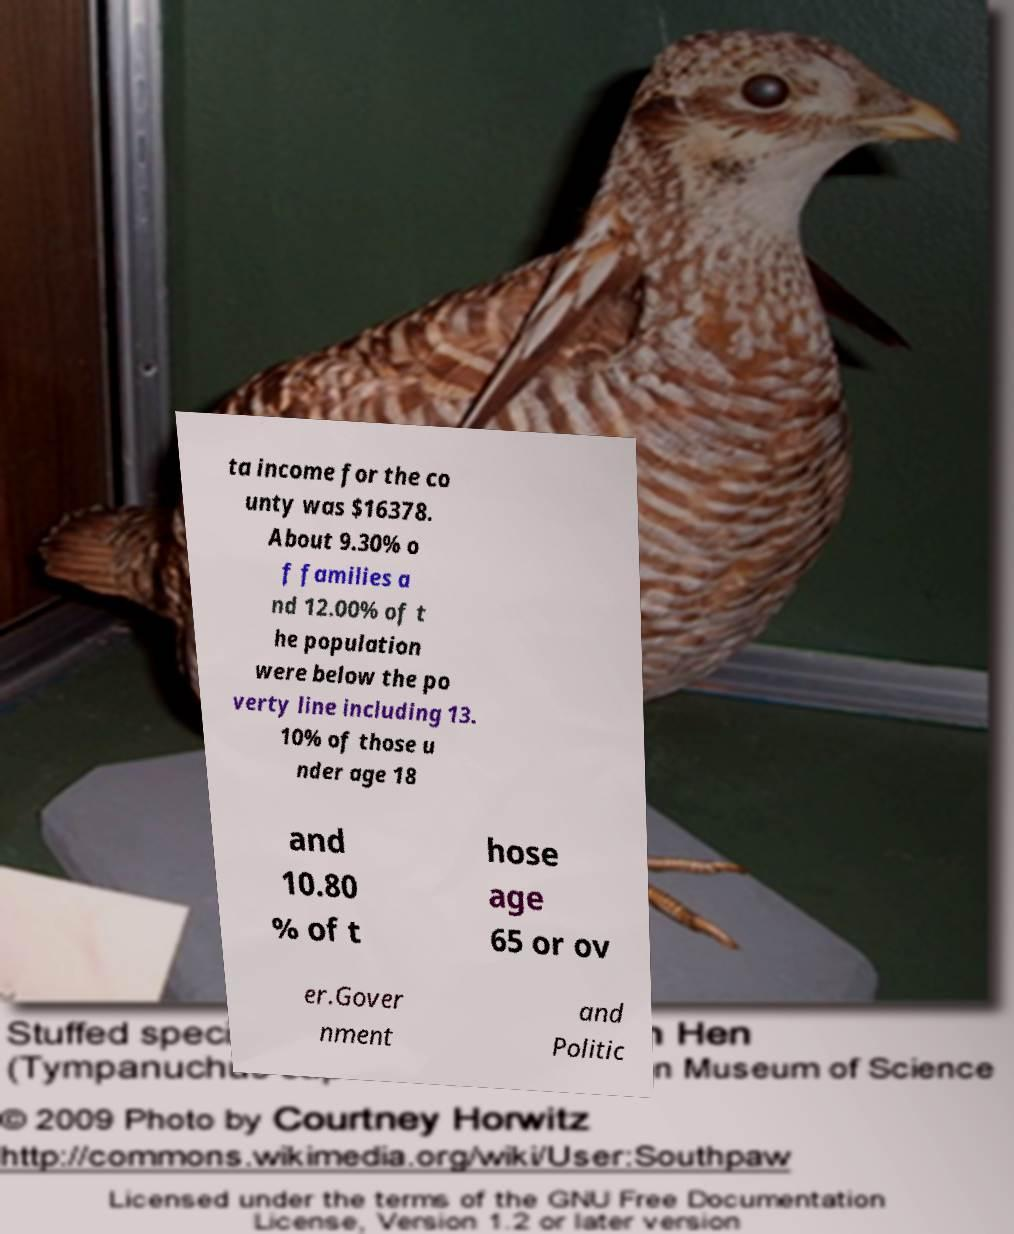Please identify and transcribe the text found in this image. ta income for the co unty was $16378. About 9.30% o f families a nd 12.00% of t he population were below the po verty line including 13. 10% of those u nder age 18 and 10.80 % of t hose age 65 or ov er.Gover nment and Politic 